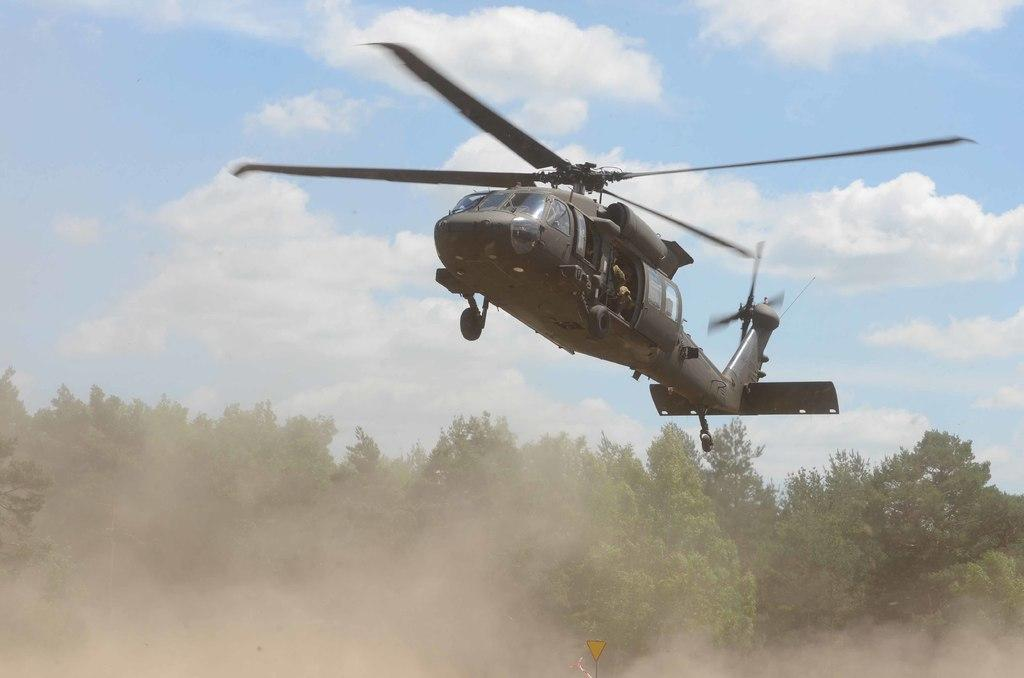What is the main subject of the image? The main subject of the image is a flying helicopter. What can be seen in the background of the image? There are trees in the image, and the sky is clouded. Is there any man-made object visible in the image besides the helicopter? Yes, there is a sign board in the image. What type of celery is being used as a prop in the image? There is no celery present in the image. What thrill can be experienced by the people in the image? The image does not depict any people, so it is not possible to determine what thrill they might be experiencing. 